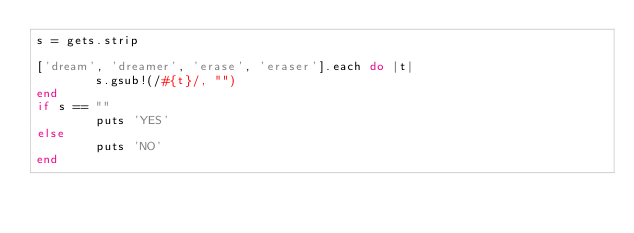Convert code to text. <code><loc_0><loc_0><loc_500><loc_500><_Ruby_>s = gets.strip

['dream', 'dreamer', 'erase', 'eraser'].each do |t|
        s.gsub!(/#{t}/, "")
end
if s == ""
        puts 'YES'
else
        puts 'NO'
end</code> 